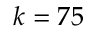<formula> <loc_0><loc_0><loc_500><loc_500>k = 7 5</formula> 